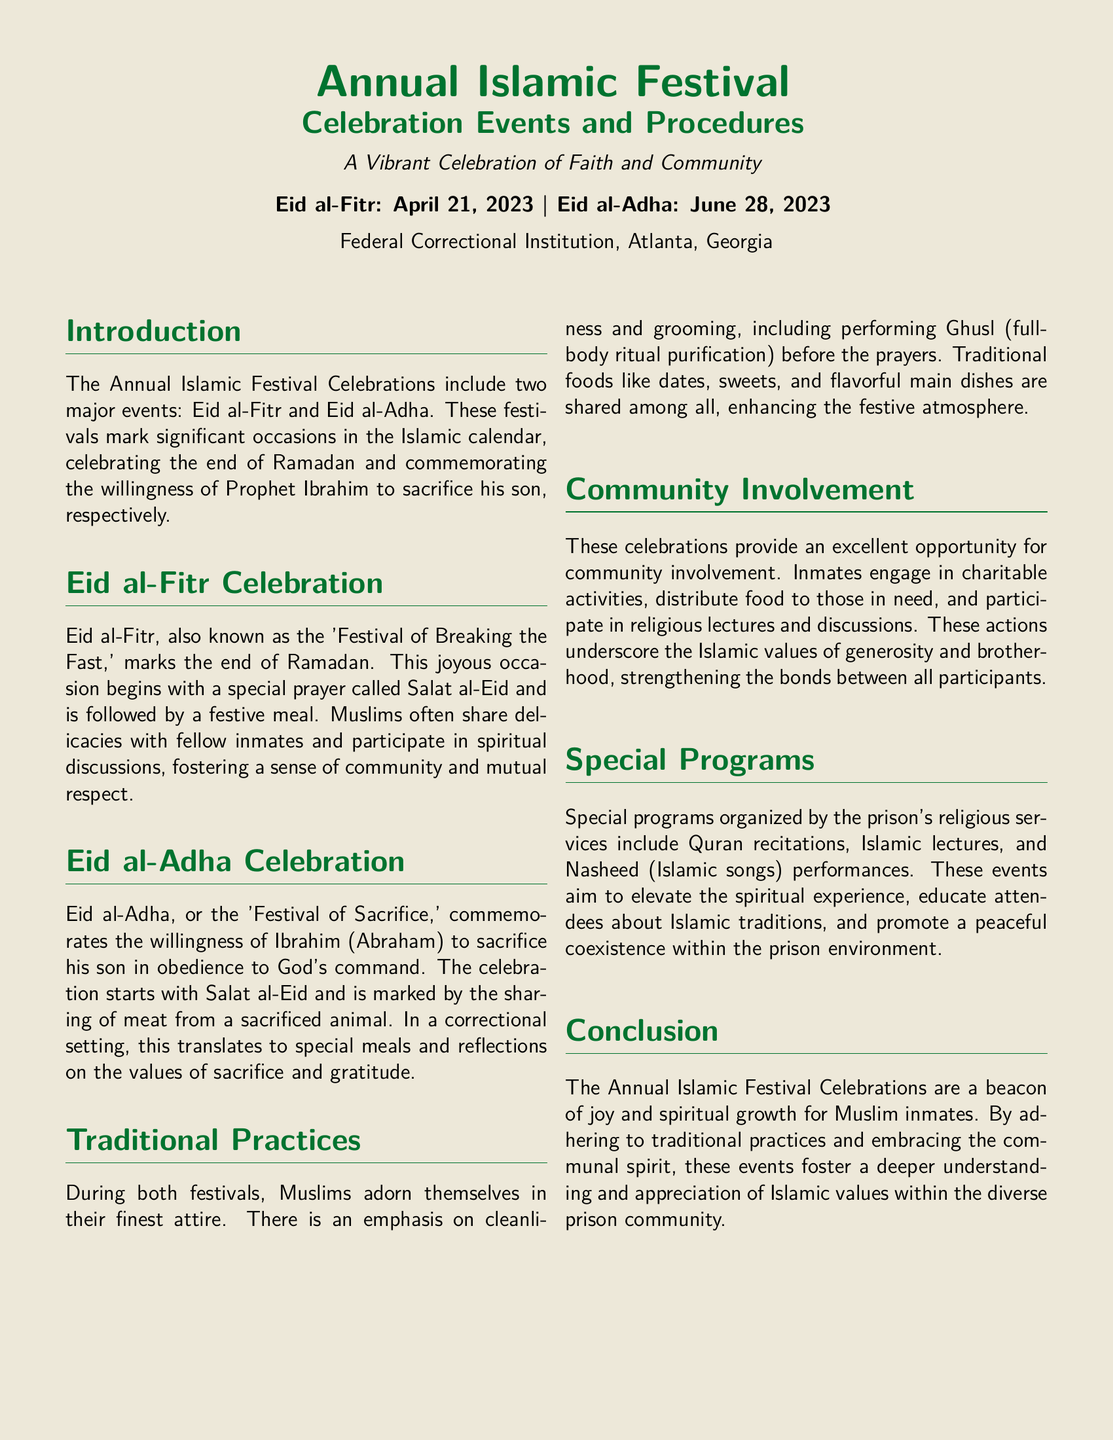What is the significance of Eid al-Fitr? The document mentions that Eid al-Fitr marks the end of Ramadan and is referred to as the 'Festival of Breaking the Fast.'
Answer: End of Ramadan What traditional practice occurs before the prayers during the festivals? The document highlights that performing Ghusl (full-body ritual purification) occurs before the prayers.
Answer: Ghusl What kind of meals are shared during Eid al-Adha? The document states that the sharing of meat from a sacrificed animal marks the celebration of Eid al-Adha.
Answer: Meat What type of activities enhance community involvement during the festival? The document explains that inmates engage in charitable activities, distribute food to those in need, and participate in religious lectures.
Answer: Charitable activities What do special programs organized by the prison's religious services include? The document lists Quran recitations, Islamic lectures, and Nasheed performances as part of special programs.
Answer: Quran recitations, Islamic lectures, Nasheed What is emphasized regarding attire during the festivals? The document states that Muslims adorn themselves in their finest attire during the festivals.
Answer: Finest attire What are the main festivals celebrated in the Annual Islamic Festival? The document identifies Eid al-Fitr and Eid al-Adha as the two main festivals.
Answer: Eid al-Fitr, Eid al-Adha 